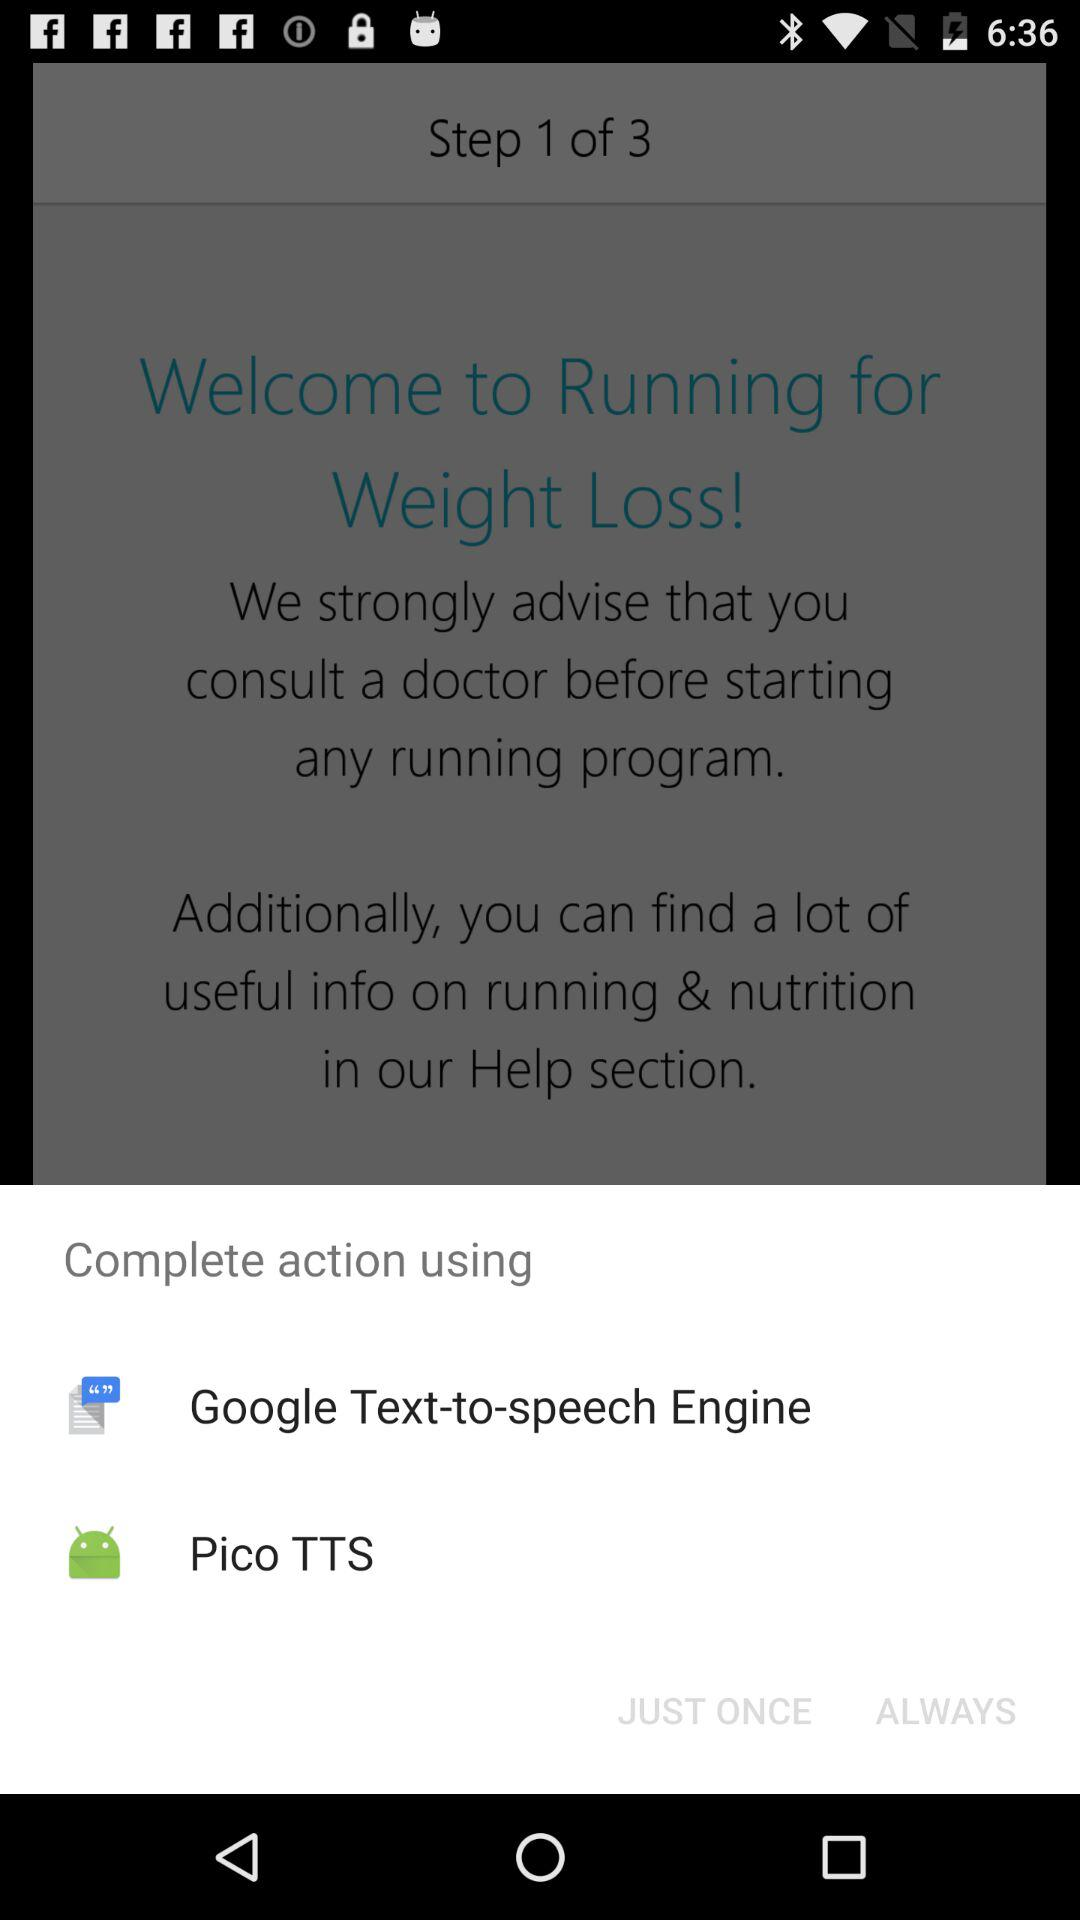What are the options to complete the action? The options to complete the action are "Google Text-to-speech Engine" and "Pico TTS". 